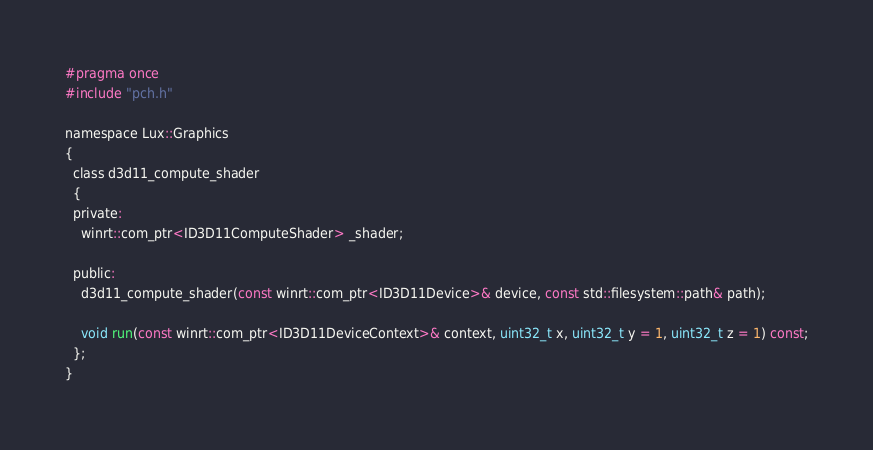Convert code to text. <code><loc_0><loc_0><loc_500><loc_500><_C_>#pragma once
#include "pch.h"

namespace Lux::Graphics
{
  class d3d11_compute_shader
  {
  private:
    winrt::com_ptr<ID3D11ComputeShader> _shader;

  public:
    d3d11_compute_shader(const winrt::com_ptr<ID3D11Device>& device, const std::filesystem::path& path);

    void run(const winrt::com_ptr<ID3D11DeviceContext>& context, uint32_t x, uint32_t y = 1, uint32_t z = 1) const;
  };
}</code> 